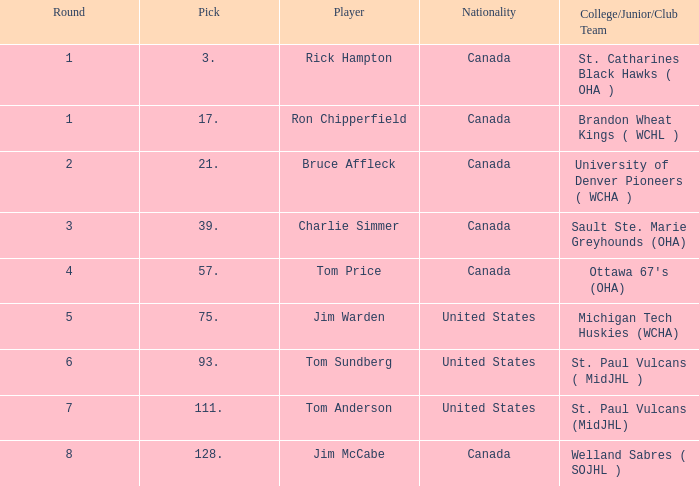Please disclose the nationality having a round smaller than 5, in addition to the player connected to bruce affleck. Canada. 